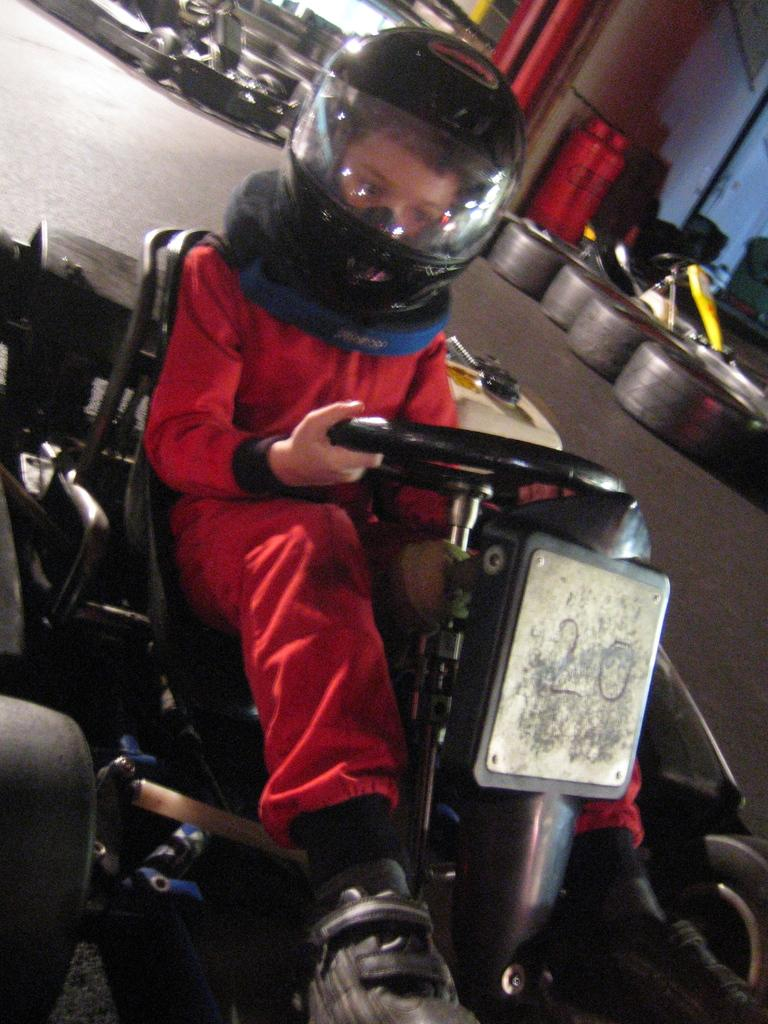What is the main subject of the image? There is a child in the image. What is the child wearing in the image? The child is wearing a helmet in the image. What is the child doing in the image? The child is sitting on a vehicle and holding the steering in the image. What can be seen in the image related to the vehicle? There are tires visible in the image. What else can be seen in the background of the image? There are other unspecified objects in the background. What type of quartz can be seen in the image? There is no quartz present in the image. What is the child discussing with others in the image? The image does not show any discussion or conversation involving the child. 